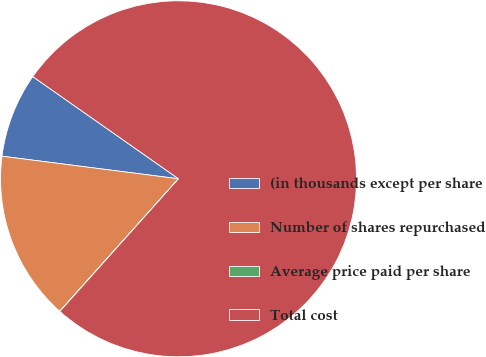Convert chart to OTSL. <chart><loc_0><loc_0><loc_500><loc_500><pie_chart><fcel>(in thousands except per share<fcel>Number of shares repurchased<fcel>Average price paid per share<fcel>Total cost<nl><fcel>7.71%<fcel>15.39%<fcel>0.02%<fcel>76.88%<nl></chart> 